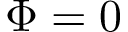<formula> <loc_0><loc_0><loc_500><loc_500>\Phi = 0</formula> 